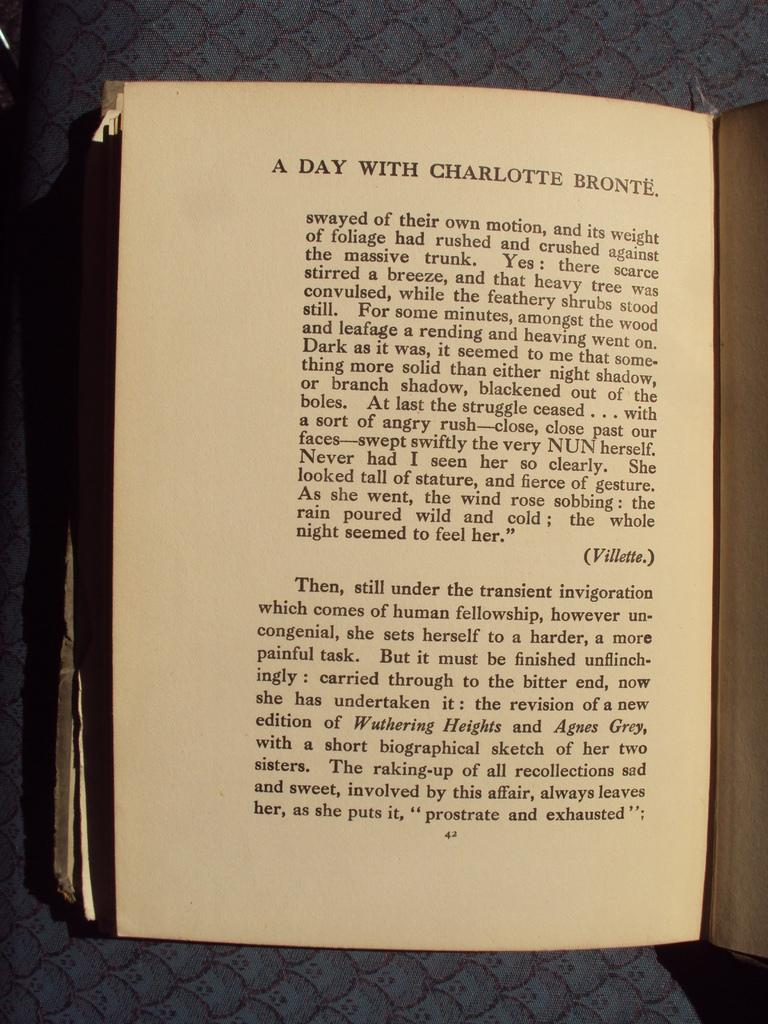<image>
Describe the image concisely. A book opened to a page that reads a day with Charlotte Bronte. 